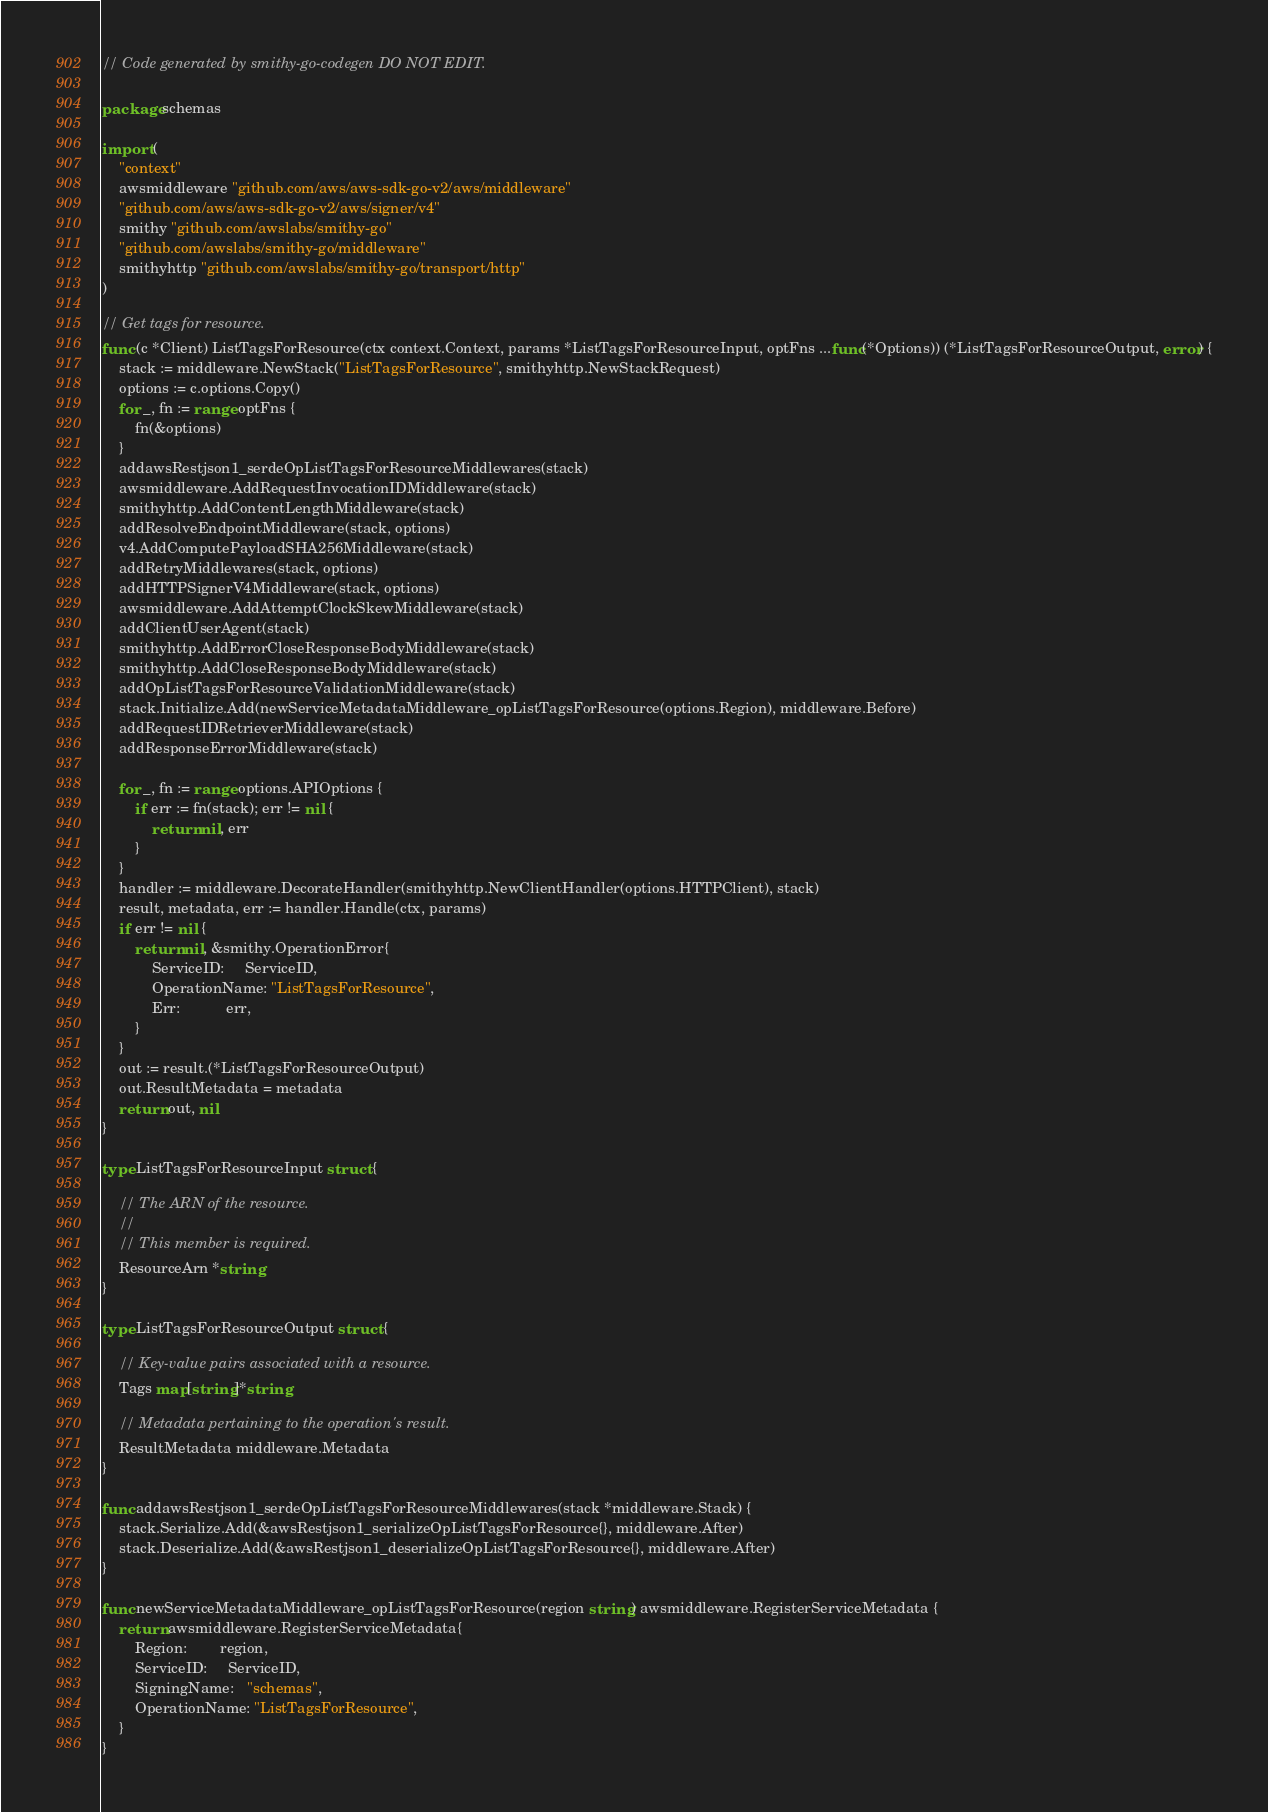Convert code to text. <code><loc_0><loc_0><loc_500><loc_500><_Go_>// Code generated by smithy-go-codegen DO NOT EDIT.

package schemas

import (
	"context"
	awsmiddleware "github.com/aws/aws-sdk-go-v2/aws/middleware"
	"github.com/aws/aws-sdk-go-v2/aws/signer/v4"
	smithy "github.com/awslabs/smithy-go"
	"github.com/awslabs/smithy-go/middleware"
	smithyhttp "github.com/awslabs/smithy-go/transport/http"
)

// Get tags for resource.
func (c *Client) ListTagsForResource(ctx context.Context, params *ListTagsForResourceInput, optFns ...func(*Options)) (*ListTagsForResourceOutput, error) {
	stack := middleware.NewStack("ListTagsForResource", smithyhttp.NewStackRequest)
	options := c.options.Copy()
	for _, fn := range optFns {
		fn(&options)
	}
	addawsRestjson1_serdeOpListTagsForResourceMiddlewares(stack)
	awsmiddleware.AddRequestInvocationIDMiddleware(stack)
	smithyhttp.AddContentLengthMiddleware(stack)
	addResolveEndpointMiddleware(stack, options)
	v4.AddComputePayloadSHA256Middleware(stack)
	addRetryMiddlewares(stack, options)
	addHTTPSignerV4Middleware(stack, options)
	awsmiddleware.AddAttemptClockSkewMiddleware(stack)
	addClientUserAgent(stack)
	smithyhttp.AddErrorCloseResponseBodyMiddleware(stack)
	smithyhttp.AddCloseResponseBodyMiddleware(stack)
	addOpListTagsForResourceValidationMiddleware(stack)
	stack.Initialize.Add(newServiceMetadataMiddleware_opListTagsForResource(options.Region), middleware.Before)
	addRequestIDRetrieverMiddleware(stack)
	addResponseErrorMiddleware(stack)

	for _, fn := range options.APIOptions {
		if err := fn(stack); err != nil {
			return nil, err
		}
	}
	handler := middleware.DecorateHandler(smithyhttp.NewClientHandler(options.HTTPClient), stack)
	result, metadata, err := handler.Handle(ctx, params)
	if err != nil {
		return nil, &smithy.OperationError{
			ServiceID:     ServiceID,
			OperationName: "ListTagsForResource",
			Err:           err,
		}
	}
	out := result.(*ListTagsForResourceOutput)
	out.ResultMetadata = metadata
	return out, nil
}

type ListTagsForResourceInput struct {

	// The ARN of the resource.
	//
	// This member is required.
	ResourceArn *string
}

type ListTagsForResourceOutput struct {

	// Key-value pairs associated with a resource.
	Tags map[string]*string

	// Metadata pertaining to the operation's result.
	ResultMetadata middleware.Metadata
}

func addawsRestjson1_serdeOpListTagsForResourceMiddlewares(stack *middleware.Stack) {
	stack.Serialize.Add(&awsRestjson1_serializeOpListTagsForResource{}, middleware.After)
	stack.Deserialize.Add(&awsRestjson1_deserializeOpListTagsForResource{}, middleware.After)
}

func newServiceMetadataMiddleware_opListTagsForResource(region string) awsmiddleware.RegisterServiceMetadata {
	return awsmiddleware.RegisterServiceMetadata{
		Region:        region,
		ServiceID:     ServiceID,
		SigningName:   "schemas",
		OperationName: "ListTagsForResource",
	}
}
</code> 